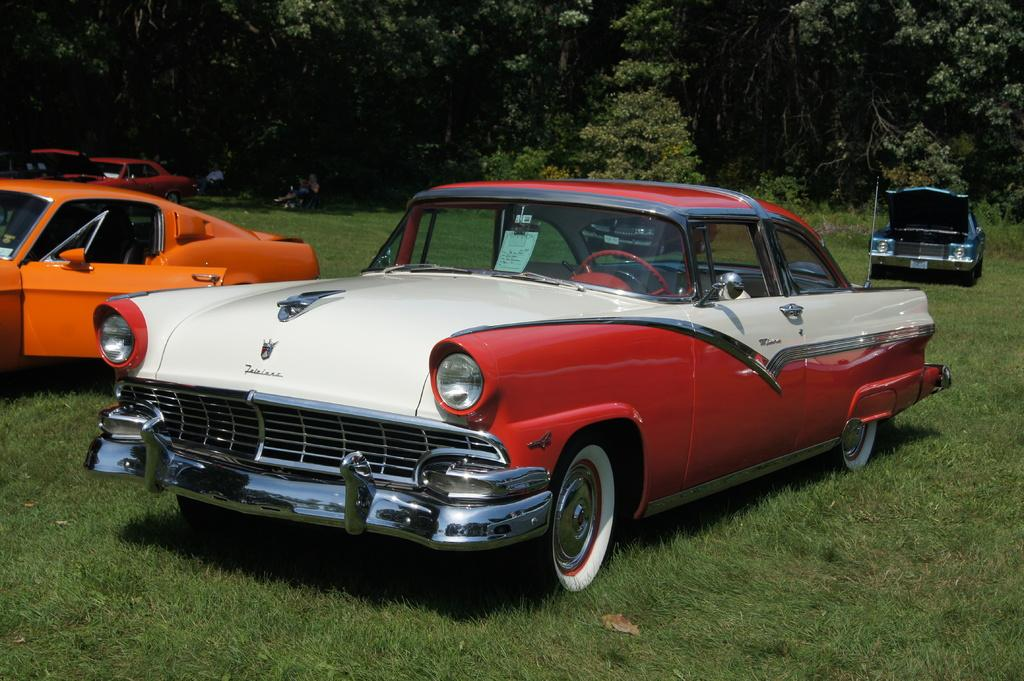What is the unusual location of the cars in the image? The cars are parked on the grass in the image. How are the cars positioned on the grass? The cars are parked on the surface of the grass. What can be seen in the background of the image? There are trees in the background of the image. What type of degree is being awarded to the person in the image? There is no person present in the image, and therefore no degree being awarded. What is the person holding on the plate in the image? There is no person or plate present in the image. 